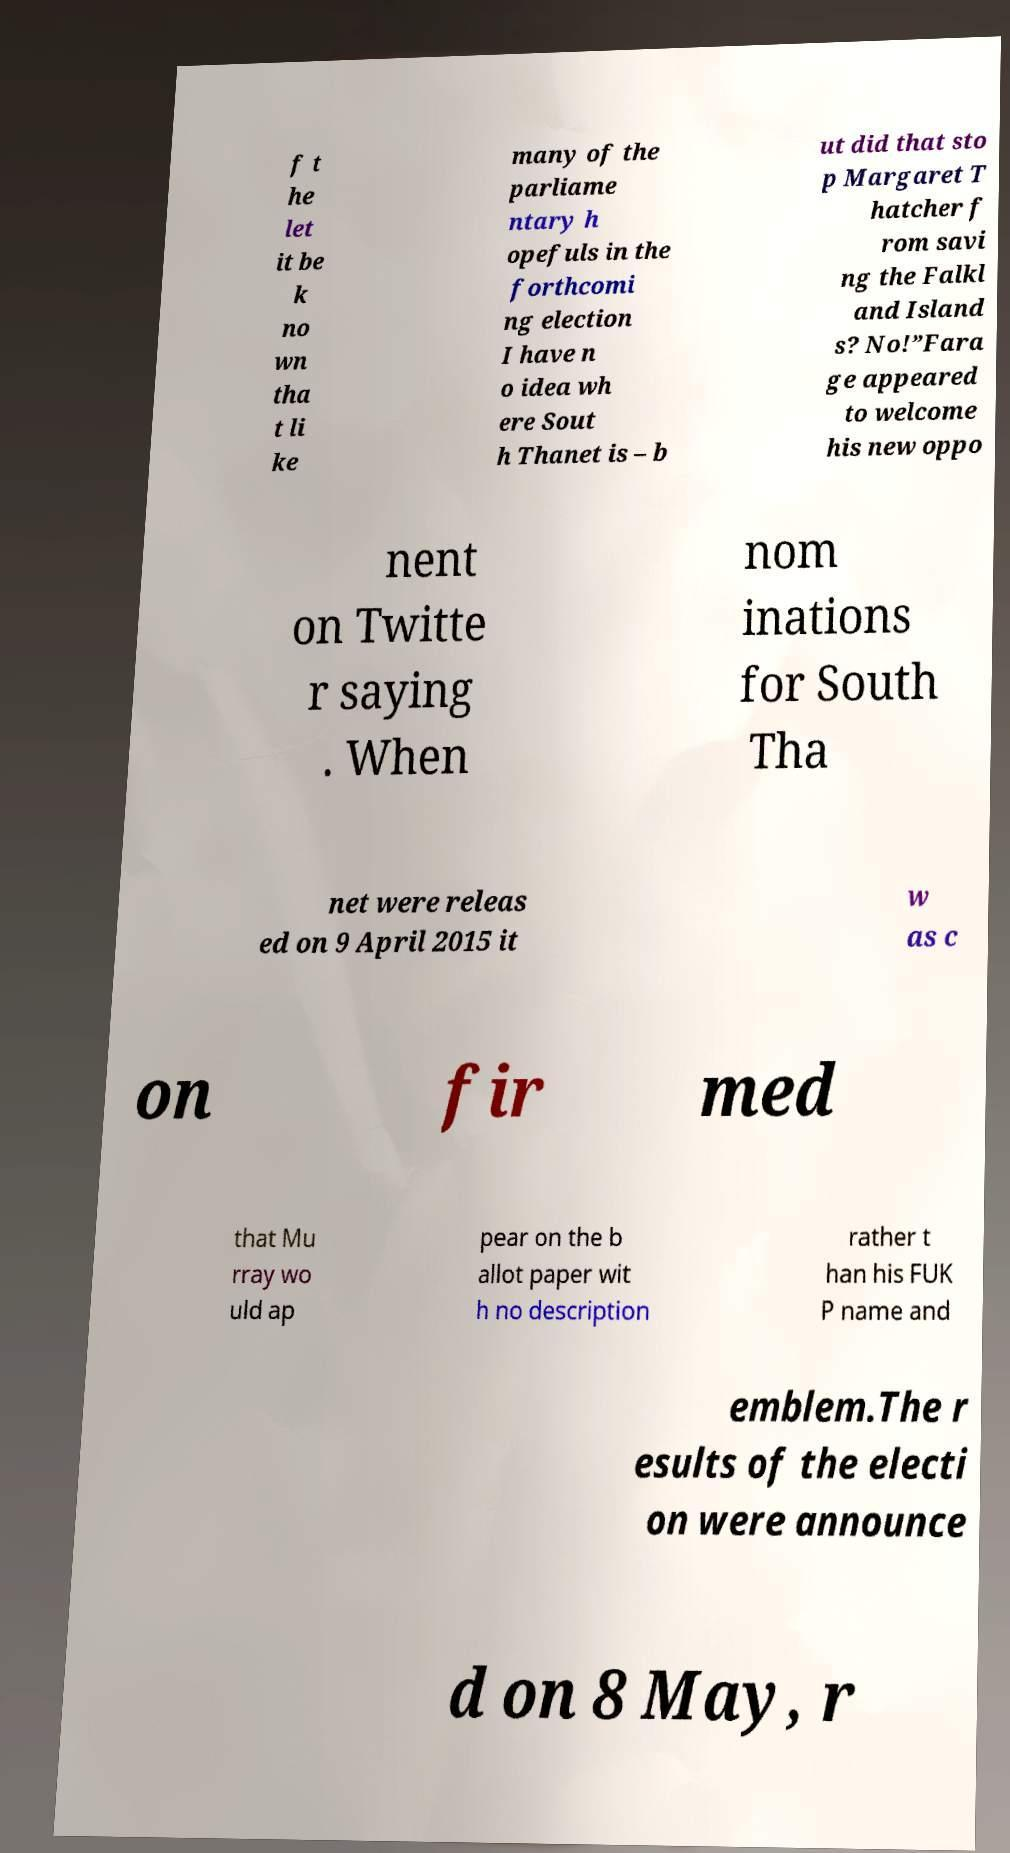Can you accurately transcribe the text from the provided image for me? f t he let it be k no wn tha t li ke many of the parliame ntary h opefuls in the forthcomi ng election I have n o idea wh ere Sout h Thanet is – b ut did that sto p Margaret T hatcher f rom savi ng the Falkl and Island s? No!”Fara ge appeared to welcome his new oppo nent on Twitte r saying . When nom inations for South Tha net were releas ed on 9 April 2015 it w as c on fir med that Mu rray wo uld ap pear on the b allot paper wit h no description rather t han his FUK P name and emblem.The r esults of the electi on were announce d on 8 May, r 